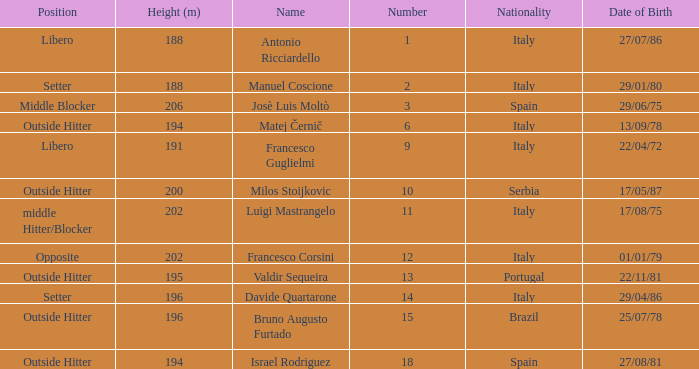Name the nationality for francesco guglielmi Italy. Could you parse the entire table as a dict? {'header': ['Position', 'Height (m)', 'Name', 'Number', 'Nationality', 'Date of Birth'], 'rows': [['Libero', '188', 'Antonio Ricciardello', '1', 'Italy', '27/07/86'], ['Setter', '188', 'Manuel Coscione', '2', 'Italy', '29/01/80'], ['Middle Blocker', '206', 'Josè Luis Moltò', '3', 'Spain', '29/06/75'], ['Outside Hitter', '194', 'Matej Černič', '6', 'Italy', '13/09/78'], ['Libero', '191', 'Francesco Guglielmi', '9', 'Italy', '22/04/72'], ['Outside Hitter', '200', 'Milos Stoijkovic', '10', 'Serbia', '17/05/87'], ['middle Hitter/Blocker', '202', 'Luigi Mastrangelo', '11', 'Italy', '17/08/75'], ['Opposite', '202', 'Francesco Corsini', '12', 'Italy', '01/01/79'], ['Outside Hitter', '195', 'Valdir Sequeira', '13', 'Portugal', '22/11/81'], ['Setter', '196', 'Davide Quartarone', '14', 'Italy', '29/04/86'], ['Outside Hitter', '196', 'Bruno Augusto Furtado', '15', 'Brazil', '25/07/78'], ['Outside Hitter', '194', 'Israel Rodriguez', '18', 'Spain', '27/08/81']]} 